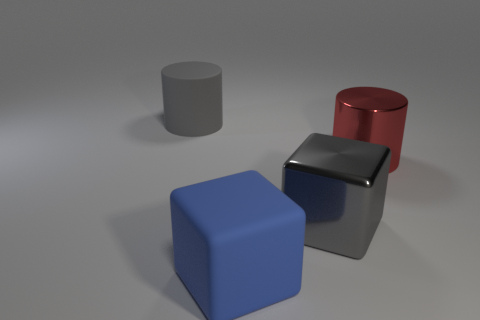Add 4 gray rubber cylinders. How many objects exist? 8 Subtract all gray objects. Subtract all large red rubber objects. How many objects are left? 2 Add 2 big red shiny objects. How many big red shiny objects are left? 3 Add 2 small gray shiny objects. How many small gray shiny objects exist? 2 Subtract 0 yellow cubes. How many objects are left? 4 